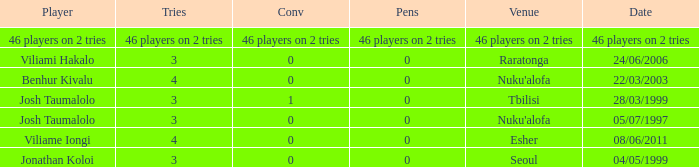What player played on 04/05/1999 with a conv of 0? Jonathan Koloi. 